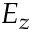<formula> <loc_0><loc_0><loc_500><loc_500>E _ { z }</formula> 